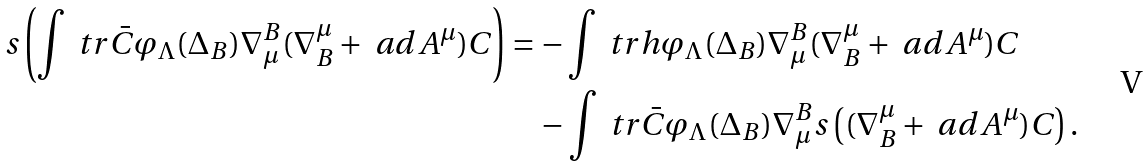Convert formula to latex. <formula><loc_0><loc_0><loc_500><loc_500>s \left ( \int \ t r \bar { C } \varphi _ { \Lambda } ( \Delta _ { B } ) \nabla _ { \mu } ^ { B } ( \nabla ^ { \mu } _ { B } + \ a d A ^ { \mu } ) C \right ) & = - \int \ t r h \varphi _ { \Lambda } ( \Delta _ { B } ) \nabla _ { \mu } ^ { B } ( \nabla ^ { \mu } _ { B } + \ a d A ^ { \mu } ) C \\ & \quad - \int \ t r \bar { C } \varphi _ { \Lambda } ( \Delta _ { B } ) \nabla _ { \mu } ^ { B } s \left ( ( \nabla ^ { \mu } _ { B } + \ a d A ^ { \mu } ) C \right ) .</formula> 